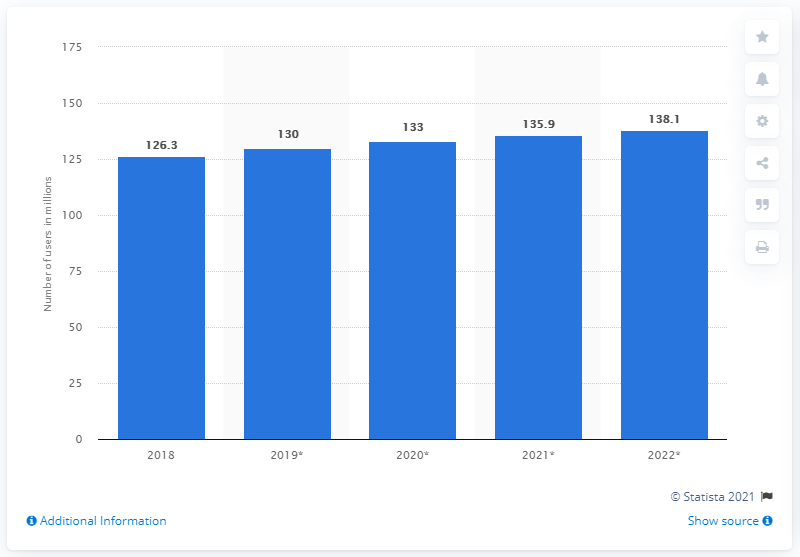Mention a couple of crucial points in this snapshot. The projected number of Facebook Messenger users in 2022 is expected to be 138.1 million. In 2018, 126.3% of U.S. mobile phone users used Facebook Messenger. 